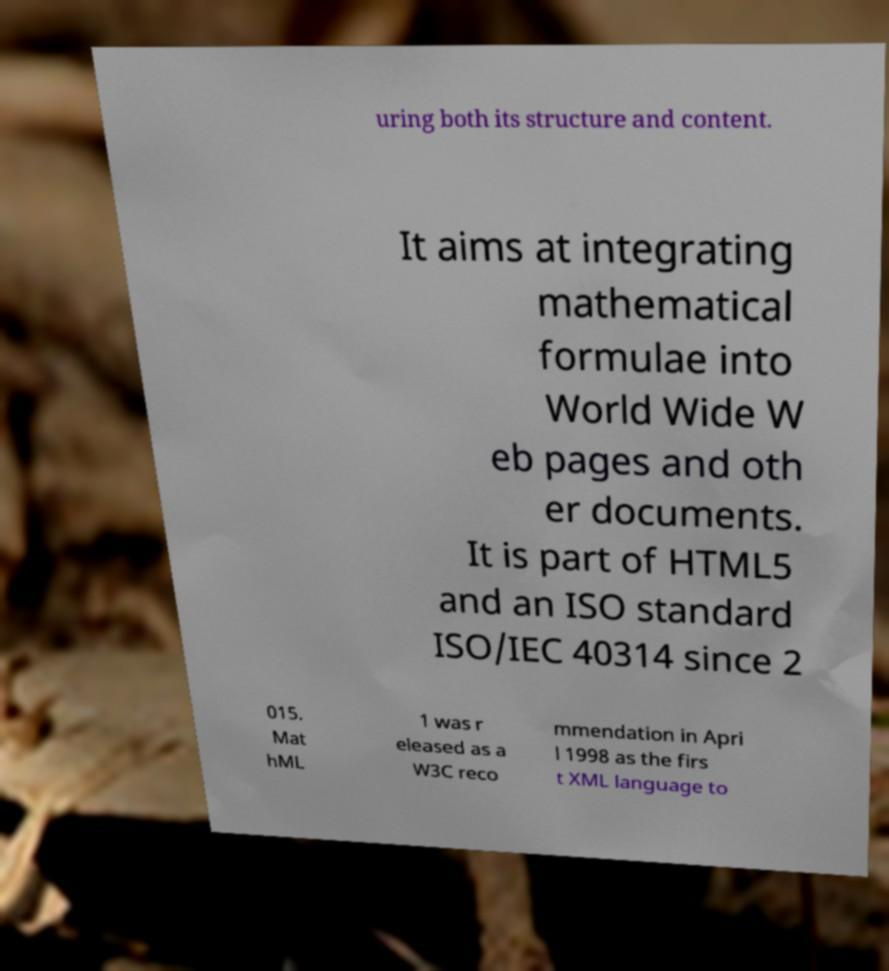For documentation purposes, I need the text within this image transcribed. Could you provide that? uring both its structure and content. It aims at integrating mathematical formulae into World Wide W eb pages and oth er documents. It is part of HTML5 and an ISO standard ISO/IEC 40314 since 2 015. Mat hML 1 was r eleased as a W3C reco mmendation in Apri l 1998 as the firs t XML language to 